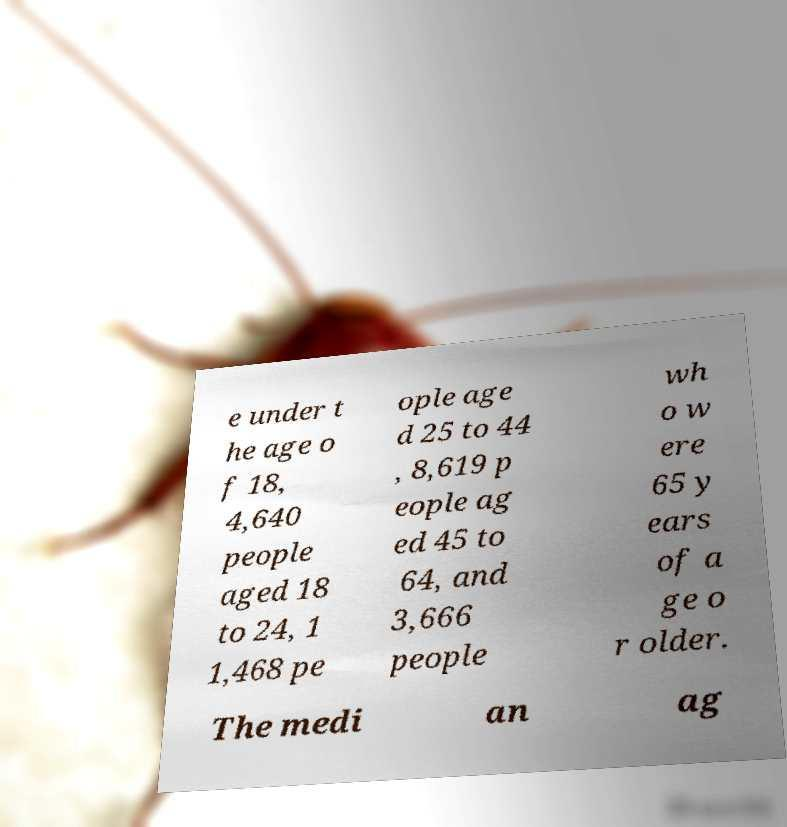Please identify and transcribe the text found in this image. e under t he age o f 18, 4,640 people aged 18 to 24, 1 1,468 pe ople age d 25 to 44 , 8,619 p eople ag ed 45 to 64, and 3,666 people wh o w ere 65 y ears of a ge o r older. The medi an ag 